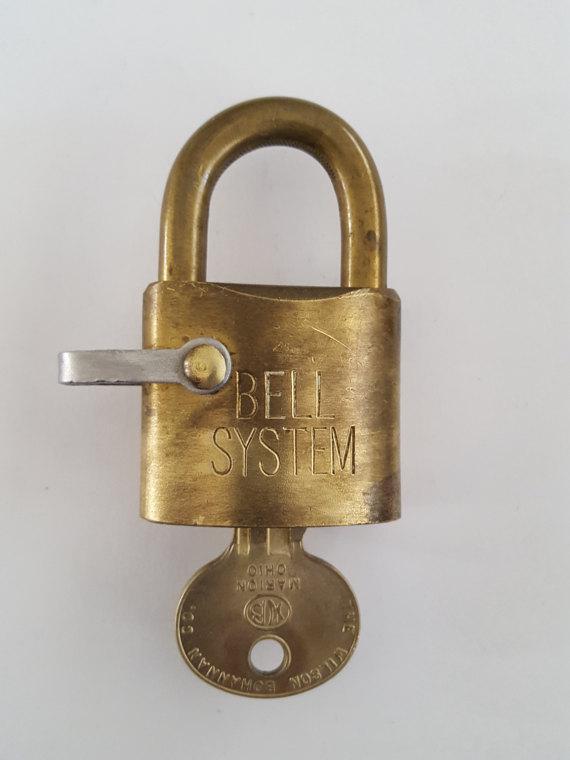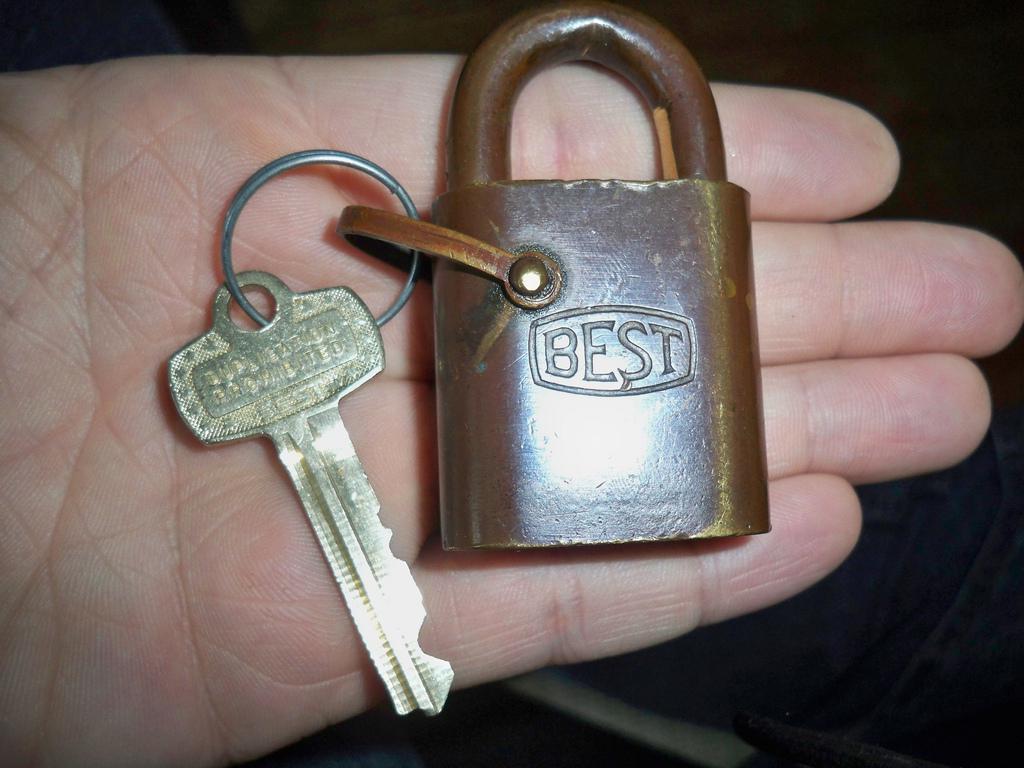The first image is the image on the left, the second image is the image on the right. Examine the images to the left and right. Is the description "A key is in a single lock in the image on the left." accurate? Answer yes or no. Yes. 